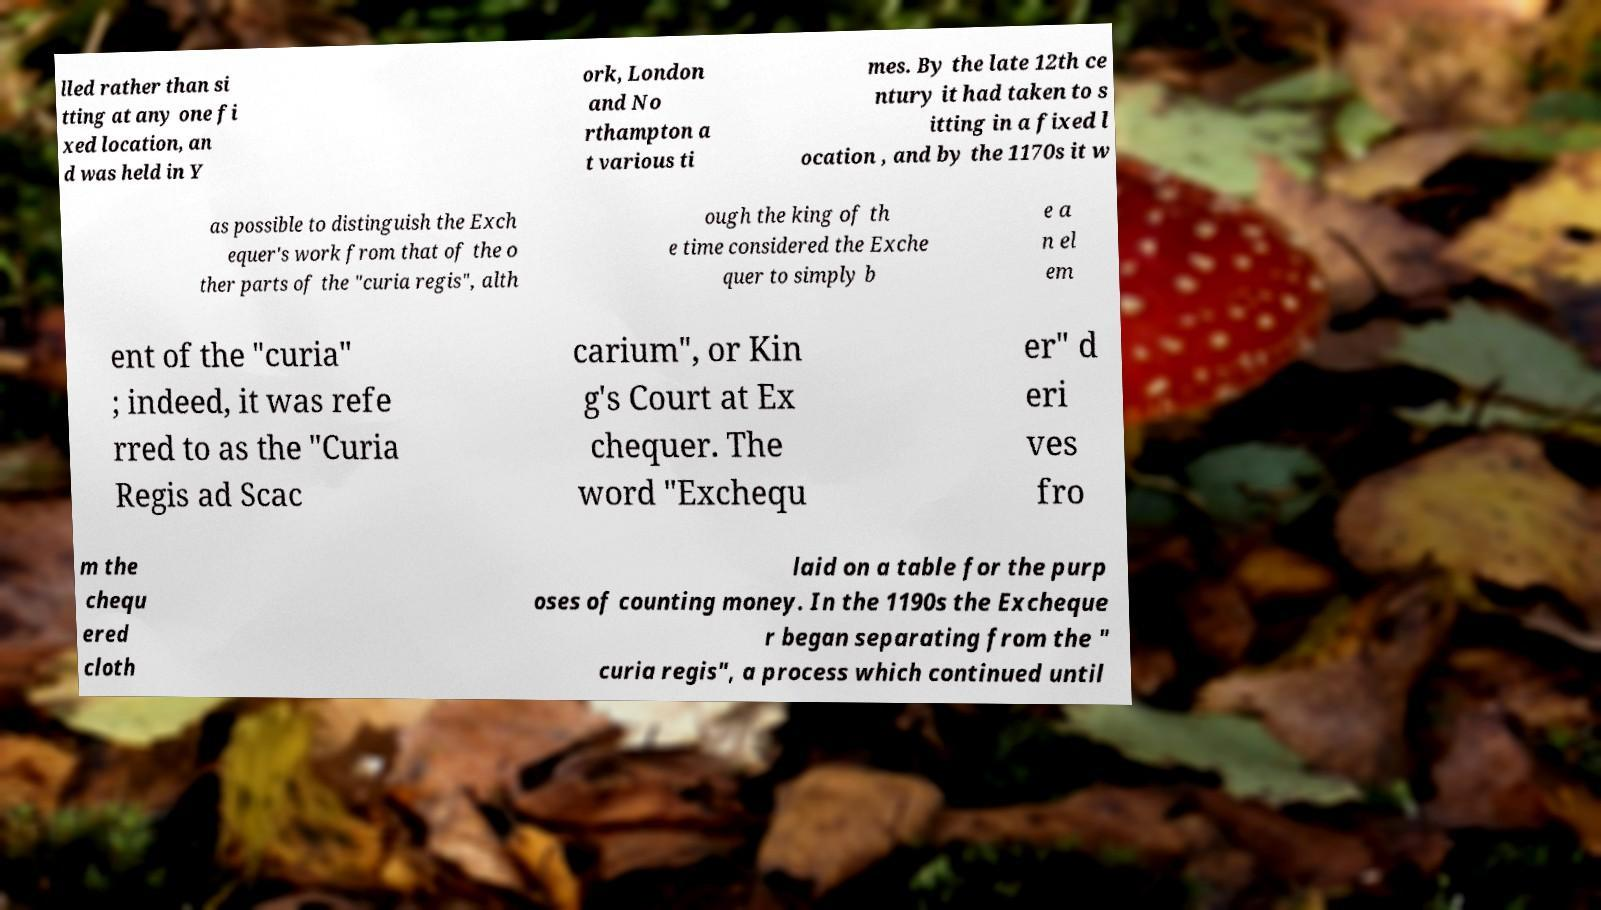Can you read and provide the text displayed in the image?This photo seems to have some interesting text. Can you extract and type it out for me? lled rather than si tting at any one fi xed location, an d was held in Y ork, London and No rthampton a t various ti mes. By the late 12th ce ntury it had taken to s itting in a fixed l ocation , and by the 1170s it w as possible to distinguish the Exch equer's work from that of the o ther parts of the "curia regis", alth ough the king of th e time considered the Exche quer to simply b e a n el em ent of the "curia" ; indeed, it was refe rred to as the "Curia Regis ad Scac carium", or Kin g's Court at Ex chequer. The word "Exchequ er" d eri ves fro m the chequ ered cloth laid on a table for the purp oses of counting money. In the 1190s the Excheque r began separating from the " curia regis", a process which continued until 